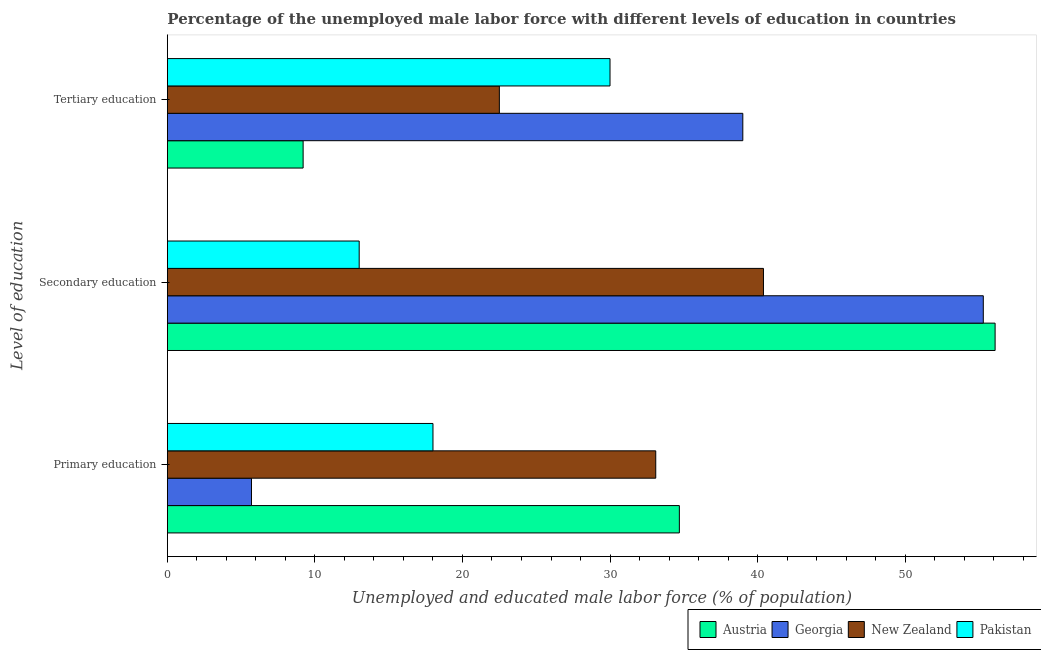How many groups of bars are there?
Provide a succinct answer. 3. Are the number of bars per tick equal to the number of legend labels?
Keep it short and to the point. Yes. Are the number of bars on each tick of the Y-axis equal?
Your answer should be compact. Yes. What is the label of the 2nd group of bars from the top?
Your response must be concise. Secondary education. What is the percentage of male labor force who received tertiary education in Austria?
Offer a terse response. 9.2. Across all countries, what is the maximum percentage of male labor force who received secondary education?
Offer a very short reply. 56.1. Across all countries, what is the minimum percentage of male labor force who received primary education?
Offer a very short reply. 5.7. In which country was the percentage of male labor force who received tertiary education maximum?
Give a very brief answer. Georgia. In which country was the percentage of male labor force who received primary education minimum?
Provide a succinct answer. Georgia. What is the total percentage of male labor force who received primary education in the graph?
Provide a succinct answer. 91.5. What is the difference between the percentage of male labor force who received tertiary education in Georgia and that in Austria?
Keep it short and to the point. 29.8. What is the difference between the percentage of male labor force who received primary education in Georgia and the percentage of male labor force who received tertiary education in New Zealand?
Provide a short and direct response. -16.8. What is the average percentage of male labor force who received secondary education per country?
Your response must be concise. 41.2. What is the difference between the percentage of male labor force who received secondary education and percentage of male labor force who received tertiary education in Pakistan?
Offer a very short reply. -17. What is the ratio of the percentage of male labor force who received secondary education in Georgia to that in Pakistan?
Your answer should be compact. 4.25. What is the difference between the highest and the second highest percentage of male labor force who received tertiary education?
Ensure brevity in your answer.  9. What is the difference between the highest and the lowest percentage of male labor force who received secondary education?
Your response must be concise. 43.1. Is the sum of the percentage of male labor force who received primary education in Austria and New Zealand greater than the maximum percentage of male labor force who received secondary education across all countries?
Make the answer very short. Yes. What does the 1st bar from the top in Secondary education represents?
Offer a terse response. Pakistan. How many bars are there?
Offer a terse response. 12. Are all the bars in the graph horizontal?
Your response must be concise. Yes. How many countries are there in the graph?
Provide a succinct answer. 4. What is the difference between two consecutive major ticks on the X-axis?
Offer a terse response. 10. Are the values on the major ticks of X-axis written in scientific E-notation?
Your answer should be very brief. No. Where does the legend appear in the graph?
Keep it short and to the point. Bottom right. How many legend labels are there?
Offer a terse response. 4. What is the title of the graph?
Your answer should be compact. Percentage of the unemployed male labor force with different levels of education in countries. Does "Belgium" appear as one of the legend labels in the graph?
Make the answer very short. No. What is the label or title of the X-axis?
Keep it short and to the point. Unemployed and educated male labor force (% of population). What is the label or title of the Y-axis?
Your answer should be very brief. Level of education. What is the Unemployed and educated male labor force (% of population) in Austria in Primary education?
Provide a short and direct response. 34.7. What is the Unemployed and educated male labor force (% of population) in Georgia in Primary education?
Your response must be concise. 5.7. What is the Unemployed and educated male labor force (% of population) of New Zealand in Primary education?
Make the answer very short. 33.1. What is the Unemployed and educated male labor force (% of population) of Pakistan in Primary education?
Offer a very short reply. 18. What is the Unemployed and educated male labor force (% of population) of Austria in Secondary education?
Ensure brevity in your answer.  56.1. What is the Unemployed and educated male labor force (% of population) of Georgia in Secondary education?
Provide a succinct answer. 55.3. What is the Unemployed and educated male labor force (% of population) in New Zealand in Secondary education?
Offer a very short reply. 40.4. What is the Unemployed and educated male labor force (% of population) in Pakistan in Secondary education?
Provide a succinct answer. 13. What is the Unemployed and educated male labor force (% of population) in Austria in Tertiary education?
Your answer should be very brief. 9.2. What is the Unemployed and educated male labor force (% of population) in New Zealand in Tertiary education?
Offer a terse response. 22.5. What is the Unemployed and educated male labor force (% of population) in Pakistan in Tertiary education?
Make the answer very short. 30. Across all Level of education, what is the maximum Unemployed and educated male labor force (% of population) of Austria?
Your answer should be compact. 56.1. Across all Level of education, what is the maximum Unemployed and educated male labor force (% of population) of Georgia?
Make the answer very short. 55.3. Across all Level of education, what is the maximum Unemployed and educated male labor force (% of population) in New Zealand?
Give a very brief answer. 40.4. Across all Level of education, what is the maximum Unemployed and educated male labor force (% of population) in Pakistan?
Offer a very short reply. 30. Across all Level of education, what is the minimum Unemployed and educated male labor force (% of population) of Austria?
Your answer should be very brief. 9.2. Across all Level of education, what is the minimum Unemployed and educated male labor force (% of population) of Georgia?
Provide a short and direct response. 5.7. Across all Level of education, what is the minimum Unemployed and educated male labor force (% of population) in New Zealand?
Offer a terse response. 22.5. What is the total Unemployed and educated male labor force (% of population) in Austria in the graph?
Offer a terse response. 100. What is the total Unemployed and educated male labor force (% of population) in Georgia in the graph?
Your response must be concise. 100. What is the total Unemployed and educated male labor force (% of population) in New Zealand in the graph?
Your answer should be very brief. 96. What is the total Unemployed and educated male labor force (% of population) in Pakistan in the graph?
Your response must be concise. 61. What is the difference between the Unemployed and educated male labor force (% of population) of Austria in Primary education and that in Secondary education?
Ensure brevity in your answer.  -21.4. What is the difference between the Unemployed and educated male labor force (% of population) in Georgia in Primary education and that in Secondary education?
Provide a succinct answer. -49.6. What is the difference between the Unemployed and educated male labor force (% of population) of Austria in Primary education and that in Tertiary education?
Your response must be concise. 25.5. What is the difference between the Unemployed and educated male labor force (% of population) in Georgia in Primary education and that in Tertiary education?
Keep it short and to the point. -33.3. What is the difference between the Unemployed and educated male labor force (% of population) of Pakistan in Primary education and that in Tertiary education?
Keep it short and to the point. -12. What is the difference between the Unemployed and educated male labor force (% of population) of Austria in Secondary education and that in Tertiary education?
Provide a succinct answer. 46.9. What is the difference between the Unemployed and educated male labor force (% of population) of Georgia in Secondary education and that in Tertiary education?
Keep it short and to the point. 16.3. What is the difference between the Unemployed and educated male labor force (% of population) of New Zealand in Secondary education and that in Tertiary education?
Offer a terse response. 17.9. What is the difference between the Unemployed and educated male labor force (% of population) of Austria in Primary education and the Unemployed and educated male labor force (% of population) of Georgia in Secondary education?
Provide a succinct answer. -20.6. What is the difference between the Unemployed and educated male labor force (% of population) of Austria in Primary education and the Unemployed and educated male labor force (% of population) of New Zealand in Secondary education?
Provide a succinct answer. -5.7. What is the difference between the Unemployed and educated male labor force (% of population) of Austria in Primary education and the Unemployed and educated male labor force (% of population) of Pakistan in Secondary education?
Your answer should be very brief. 21.7. What is the difference between the Unemployed and educated male labor force (% of population) of Georgia in Primary education and the Unemployed and educated male labor force (% of population) of New Zealand in Secondary education?
Your response must be concise. -34.7. What is the difference between the Unemployed and educated male labor force (% of population) of New Zealand in Primary education and the Unemployed and educated male labor force (% of population) of Pakistan in Secondary education?
Offer a terse response. 20.1. What is the difference between the Unemployed and educated male labor force (% of population) of Austria in Primary education and the Unemployed and educated male labor force (% of population) of Georgia in Tertiary education?
Your answer should be very brief. -4.3. What is the difference between the Unemployed and educated male labor force (% of population) in Georgia in Primary education and the Unemployed and educated male labor force (% of population) in New Zealand in Tertiary education?
Make the answer very short. -16.8. What is the difference between the Unemployed and educated male labor force (% of population) in Georgia in Primary education and the Unemployed and educated male labor force (% of population) in Pakistan in Tertiary education?
Your response must be concise. -24.3. What is the difference between the Unemployed and educated male labor force (% of population) in Austria in Secondary education and the Unemployed and educated male labor force (% of population) in New Zealand in Tertiary education?
Your response must be concise. 33.6. What is the difference between the Unemployed and educated male labor force (% of population) in Austria in Secondary education and the Unemployed and educated male labor force (% of population) in Pakistan in Tertiary education?
Give a very brief answer. 26.1. What is the difference between the Unemployed and educated male labor force (% of population) in Georgia in Secondary education and the Unemployed and educated male labor force (% of population) in New Zealand in Tertiary education?
Keep it short and to the point. 32.8. What is the difference between the Unemployed and educated male labor force (% of population) in Georgia in Secondary education and the Unemployed and educated male labor force (% of population) in Pakistan in Tertiary education?
Offer a terse response. 25.3. What is the difference between the Unemployed and educated male labor force (% of population) of New Zealand in Secondary education and the Unemployed and educated male labor force (% of population) of Pakistan in Tertiary education?
Give a very brief answer. 10.4. What is the average Unemployed and educated male labor force (% of population) of Austria per Level of education?
Your answer should be compact. 33.33. What is the average Unemployed and educated male labor force (% of population) in Georgia per Level of education?
Provide a succinct answer. 33.33. What is the average Unemployed and educated male labor force (% of population) of New Zealand per Level of education?
Make the answer very short. 32. What is the average Unemployed and educated male labor force (% of population) in Pakistan per Level of education?
Your answer should be very brief. 20.33. What is the difference between the Unemployed and educated male labor force (% of population) in Austria and Unemployed and educated male labor force (% of population) in Pakistan in Primary education?
Offer a very short reply. 16.7. What is the difference between the Unemployed and educated male labor force (% of population) in Georgia and Unemployed and educated male labor force (% of population) in New Zealand in Primary education?
Make the answer very short. -27.4. What is the difference between the Unemployed and educated male labor force (% of population) in Austria and Unemployed and educated male labor force (% of population) in Pakistan in Secondary education?
Provide a short and direct response. 43.1. What is the difference between the Unemployed and educated male labor force (% of population) of Georgia and Unemployed and educated male labor force (% of population) of Pakistan in Secondary education?
Your response must be concise. 42.3. What is the difference between the Unemployed and educated male labor force (% of population) in New Zealand and Unemployed and educated male labor force (% of population) in Pakistan in Secondary education?
Your answer should be compact. 27.4. What is the difference between the Unemployed and educated male labor force (% of population) of Austria and Unemployed and educated male labor force (% of population) of Georgia in Tertiary education?
Your answer should be compact. -29.8. What is the difference between the Unemployed and educated male labor force (% of population) in Austria and Unemployed and educated male labor force (% of population) in Pakistan in Tertiary education?
Keep it short and to the point. -20.8. What is the difference between the Unemployed and educated male labor force (% of population) of Georgia and Unemployed and educated male labor force (% of population) of New Zealand in Tertiary education?
Your answer should be very brief. 16.5. What is the difference between the Unemployed and educated male labor force (% of population) in Georgia and Unemployed and educated male labor force (% of population) in Pakistan in Tertiary education?
Keep it short and to the point. 9. What is the difference between the Unemployed and educated male labor force (% of population) of New Zealand and Unemployed and educated male labor force (% of population) of Pakistan in Tertiary education?
Offer a very short reply. -7.5. What is the ratio of the Unemployed and educated male labor force (% of population) of Austria in Primary education to that in Secondary education?
Give a very brief answer. 0.62. What is the ratio of the Unemployed and educated male labor force (% of population) of Georgia in Primary education to that in Secondary education?
Give a very brief answer. 0.1. What is the ratio of the Unemployed and educated male labor force (% of population) in New Zealand in Primary education to that in Secondary education?
Provide a succinct answer. 0.82. What is the ratio of the Unemployed and educated male labor force (% of population) in Pakistan in Primary education to that in Secondary education?
Your answer should be compact. 1.38. What is the ratio of the Unemployed and educated male labor force (% of population) in Austria in Primary education to that in Tertiary education?
Your response must be concise. 3.77. What is the ratio of the Unemployed and educated male labor force (% of population) in Georgia in Primary education to that in Tertiary education?
Provide a succinct answer. 0.15. What is the ratio of the Unemployed and educated male labor force (% of population) in New Zealand in Primary education to that in Tertiary education?
Offer a terse response. 1.47. What is the ratio of the Unemployed and educated male labor force (% of population) in Austria in Secondary education to that in Tertiary education?
Offer a terse response. 6.1. What is the ratio of the Unemployed and educated male labor force (% of population) in Georgia in Secondary education to that in Tertiary education?
Offer a terse response. 1.42. What is the ratio of the Unemployed and educated male labor force (% of population) in New Zealand in Secondary education to that in Tertiary education?
Ensure brevity in your answer.  1.8. What is the ratio of the Unemployed and educated male labor force (% of population) of Pakistan in Secondary education to that in Tertiary education?
Offer a very short reply. 0.43. What is the difference between the highest and the second highest Unemployed and educated male labor force (% of population) of Austria?
Give a very brief answer. 21.4. What is the difference between the highest and the second highest Unemployed and educated male labor force (% of population) in New Zealand?
Offer a very short reply. 7.3. What is the difference between the highest and the second highest Unemployed and educated male labor force (% of population) in Pakistan?
Offer a terse response. 12. What is the difference between the highest and the lowest Unemployed and educated male labor force (% of population) in Austria?
Make the answer very short. 46.9. What is the difference between the highest and the lowest Unemployed and educated male labor force (% of population) of Georgia?
Offer a very short reply. 49.6. 